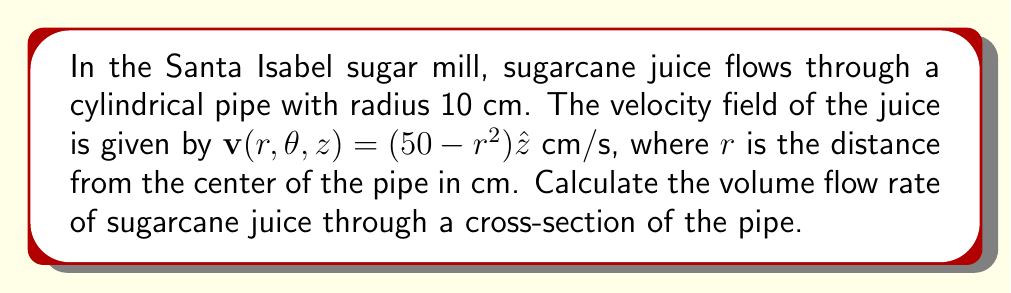Provide a solution to this math problem. Let's approach this step-by-step:

1) The volume flow rate is given by the flux of the velocity field across a cross-section of the pipe. We can calculate this using the surface integral:

   $$Q = \iint_S \mathbf{v} \cdot \mathbf{n} \, dS$$

   where $\mathbf{n}$ is the unit normal vector to the surface.

2) In this case, the surface is a circular cross-section of the pipe, and $\mathbf{n} = \hat{z}$.

3) The dot product $\mathbf{v} \cdot \mathbf{n} = (50-r^2)$.

4) We can use polar coordinates to set up the integral:

   $$Q = \int_0^{2\pi} \int_0^{10} (50-r^2) \, r \, dr \, d\theta$$

5) Let's solve the inner integral first:

   $$\int_0^{10} (50-r^2) \, r \, dr = \left[50\frac{r^2}{2} - \frac{r^4}{4}\right]_0^{10}$$
   $$= \left(2500 - 2500\right) - (0 - 0) = 0$$

6) Now, the outer integral:

   $$Q = \int_0^{2\pi} 0 \, d\theta = 0$$

7) To convert to m³/s, we multiply by $(0.01)^3$ to convert from cm³/s to m³/s.
Answer: 0 m³/s 